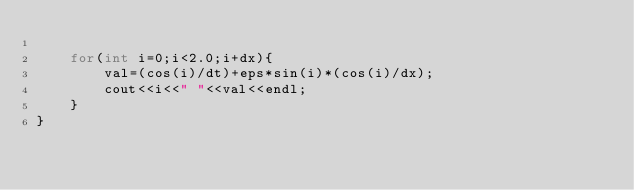<code> <loc_0><loc_0><loc_500><loc_500><_C++_>    
    for(int i=0;i<2.0;i+dx){
        val=(cos(i)/dt)+eps*sin(i)*(cos(i)/dx);
        cout<<i<<" "<<val<<endl;
    }
}</code> 